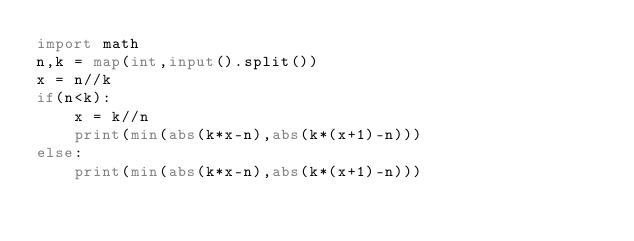Convert code to text. <code><loc_0><loc_0><loc_500><loc_500><_Python_>import math
n,k = map(int,input().split())
x = n//k
if(n<k):
    x = k//n
    print(min(abs(k*x-n),abs(k*(x+1)-n)))
else:
    print(min(abs(k*x-n),abs(k*(x+1)-n)))</code> 